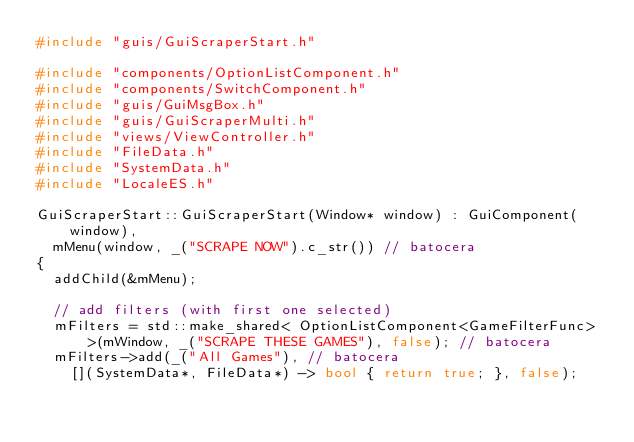<code> <loc_0><loc_0><loc_500><loc_500><_C++_>#include "guis/GuiScraperStart.h"

#include "components/OptionListComponent.h"
#include "components/SwitchComponent.h"
#include "guis/GuiMsgBox.h"
#include "guis/GuiScraperMulti.h"
#include "views/ViewController.h"
#include "FileData.h"
#include "SystemData.h"
#include "LocaleES.h"

GuiScraperStart::GuiScraperStart(Window* window) : GuiComponent(window),
  mMenu(window, _("SCRAPE NOW").c_str()) // batocera
{
	addChild(&mMenu);

	// add filters (with first one selected)
	mFilters = std::make_shared< OptionListComponent<GameFilterFunc> >(mWindow, _("SCRAPE THESE GAMES"), false); // batocera
	mFilters->add(_("All Games"), // batocera
		[](SystemData*, FileData*) -> bool { return true; }, false);</code> 